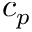<formula> <loc_0><loc_0><loc_500><loc_500>c _ { p }</formula> 